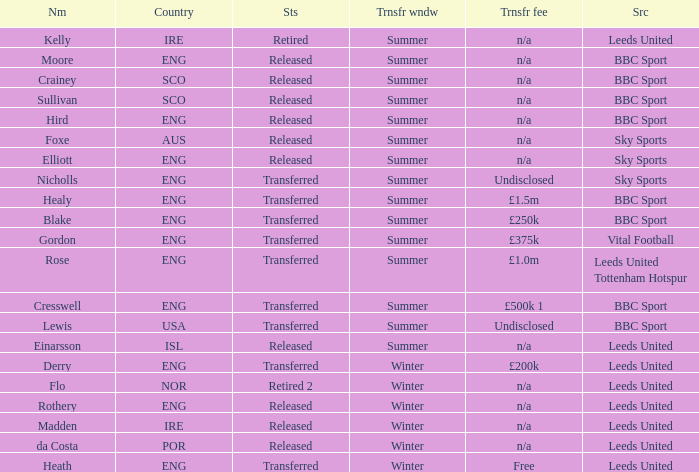What was the source for the person named Cresswell? BBC Sport. 